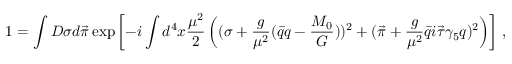<formula> <loc_0><loc_0><loc_500><loc_500>1 = \int D \sigma d \vec { \pi } \exp \left [ - i \int d ^ { 4 } x { \frac { \mu ^ { 2 } } { 2 } } \left ( ( \sigma + { \frac { g } { \mu ^ { 2 } } } ( \bar { q } q - { \frac { M _ { 0 } } { G } } ) ) ^ { 2 } + ( \vec { \pi } + { \frac { g } { \mu ^ { 2 } } } \bar { q } i \vec { \tau } \gamma _ { 5 } q ) ^ { 2 } \right ) \right ] \, ,</formula> 